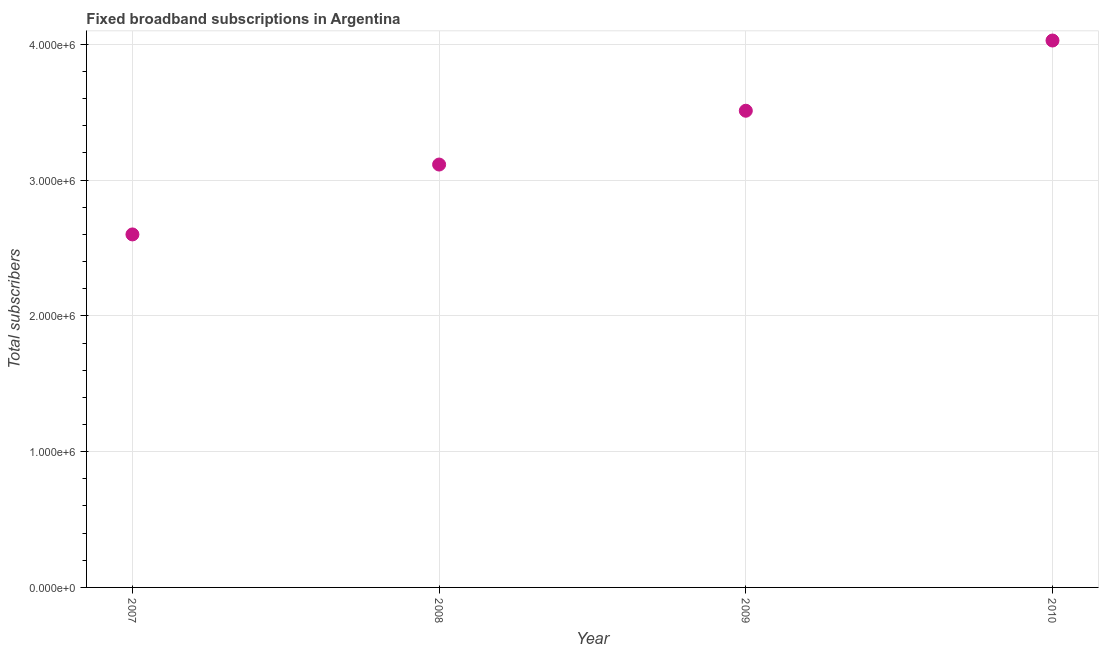What is the total number of fixed broadband subscriptions in 2009?
Ensure brevity in your answer.  3.51e+06. Across all years, what is the maximum total number of fixed broadband subscriptions?
Offer a terse response. 4.03e+06. Across all years, what is the minimum total number of fixed broadband subscriptions?
Offer a very short reply. 2.60e+06. What is the sum of the total number of fixed broadband subscriptions?
Your response must be concise. 1.33e+07. What is the difference between the total number of fixed broadband subscriptions in 2009 and 2010?
Your response must be concise. -5.17e+05. What is the average total number of fixed broadband subscriptions per year?
Offer a terse response. 3.31e+06. What is the median total number of fixed broadband subscriptions?
Provide a succinct answer. 3.31e+06. Do a majority of the years between 2009 and 2008 (inclusive) have total number of fixed broadband subscriptions greater than 3800000 ?
Keep it short and to the point. No. What is the ratio of the total number of fixed broadband subscriptions in 2007 to that in 2009?
Make the answer very short. 0.74. Is the difference between the total number of fixed broadband subscriptions in 2007 and 2010 greater than the difference between any two years?
Make the answer very short. Yes. What is the difference between the highest and the second highest total number of fixed broadband subscriptions?
Offer a terse response. 5.17e+05. What is the difference between the highest and the lowest total number of fixed broadband subscriptions?
Make the answer very short. 1.43e+06. Does the total number of fixed broadband subscriptions monotonically increase over the years?
Give a very brief answer. Yes. How many dotlines are there?
Provide a succinct answer. 1. Does the graph contain any zero values?
Offer a very short reply. No. Does the graph contain grids?
Ensure brevity in your answer.  Yes. What is the title of the graph?
Ensure brevity in your answer.  Fixed broadband subscriptions in Argentina. What is the label or title of the X-axis?
Your response must be concise. Year. What is the label or title of the Y-axis?
Provide a short and direct response. Total subscribers. What is the Total subscribers in 2007?
Keep it short and to the point. 2.60e+06. What is the Total subscribers in 2008?
Your answer should be compact. 3.11e+06. What is the Total subscribers in 2009?
Keep it short and to the point. 3.51e+06. What is the Total subscribers in 2010?
Provide a succinct answer. 4.03e+06. What is the difference between the Total subscribers in 2007 and 2008?
Offer a very short reply. -5.15e+05. What is the difference between the Total subscribers in 2007 and 2009?
Provide a short and direct response. -9.11e+05. What is the difference between the Total subscribers in 2007 and 2010?
Give a very brief answer. -1.43e+06. What is the difference between the Total subscribers in 2008 and 2009?
Keep it short and to the point. -3.96e+05. What is the difference between the Total subscribers in 2008 and 2010?
Give a very brief answer. -9.13e+05. What is the difference between the Total subscribers in 2009 and 2010?
Ensure brevity in your answer.  -5.17e+05. What is the ratio of the Total subscribers in 2007 to that in 2008?
Your answer should be compact. 0.83. What is the ratio of the Total subscribers in 2007 to that in 2009?
Your response must be concise. 0.74. What is the ratio of the Total subscribers in 2007 to that in 2010?
Make the answer very short. 0.65. What is the ratio of the Total subscribers in 2008 to that in 2009?
Keep it short and to the point. 0.89. What is the ratio of the Total subscribers in 2008 to that in 2010?
Offer a very short reply. 0.77. What is the ratio of the Total subscribers in 2009 to that in 2010?
Provide a succinct answer. 0.87. 